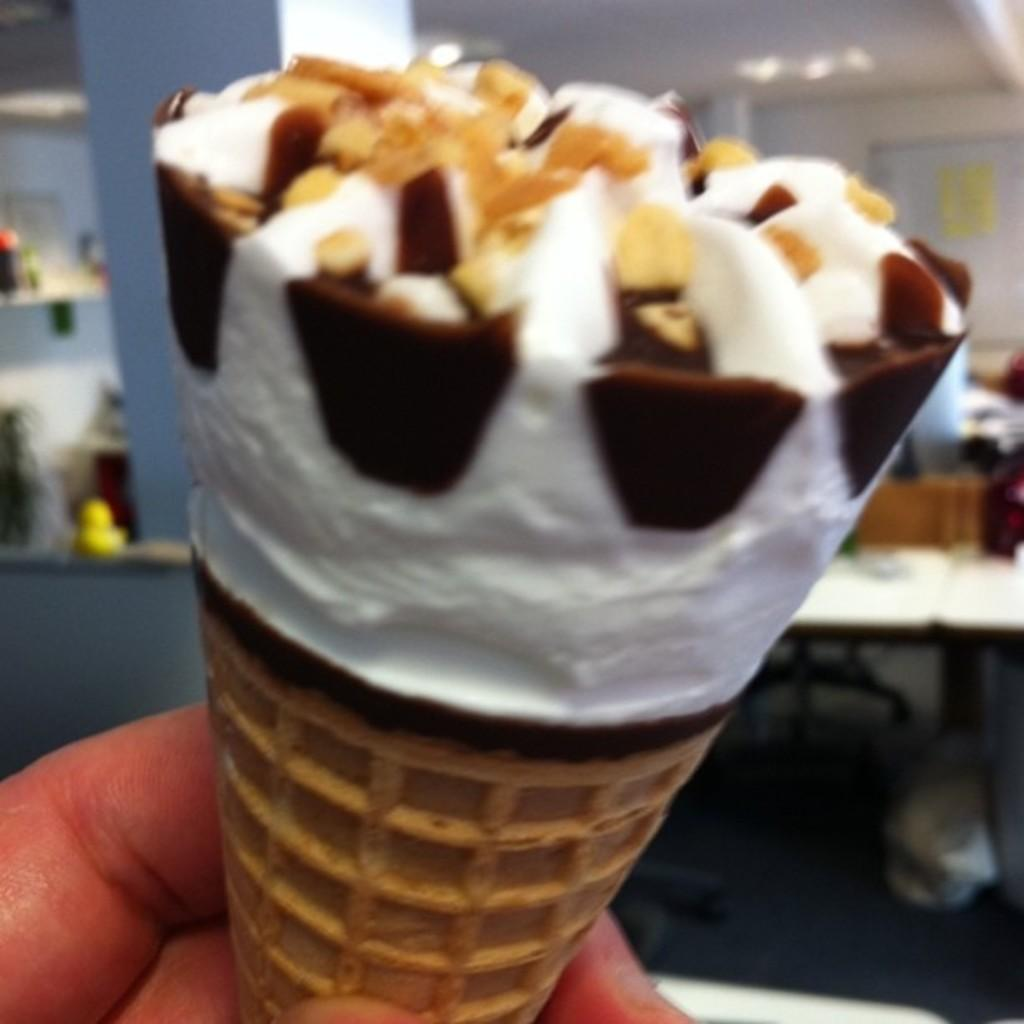What is being held by the human hand in the image? A human hand is holding an ice cream in the image. Can you describe the position or gesture of the hand? The position or gesture of the hand is not specified in the provided facts. What might the person holding the ice cream be doing or planning to do? The person might be about to eat the ice cream, but their specific intentions are not mentioned in the facts. How many scarecrows can be seen adjusting the bridge in the image? There are no scarecrows or bridges present in the image; it features a human hand holding an ice cream. 